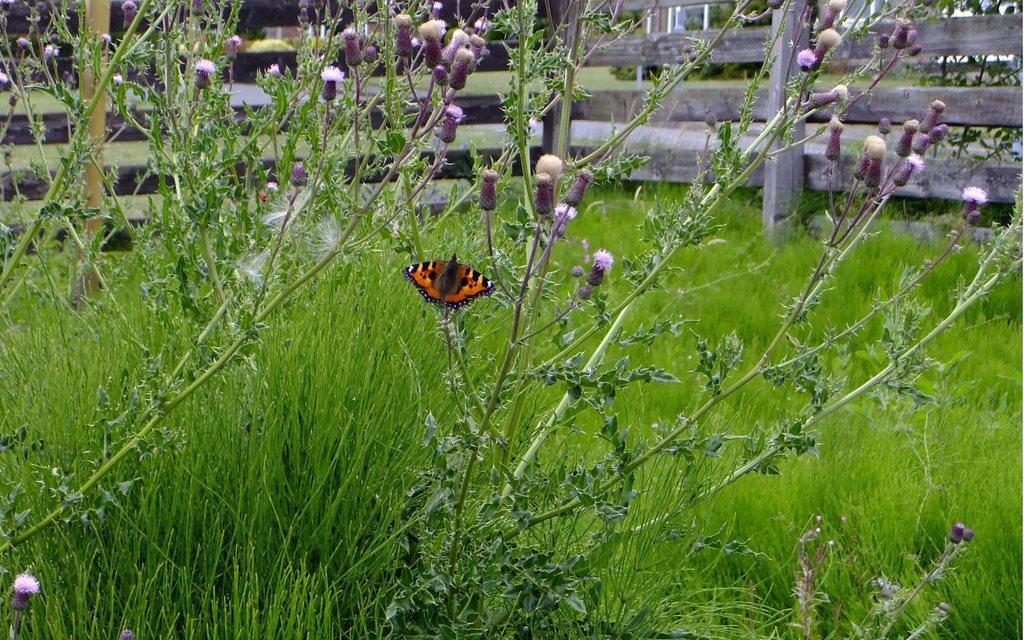Please provide a concise description of this image. In this picture in the middle, we can see a butterfly which is attached to a plant. In the background, we can see some plants, flowers, wood grill, trees, at the bottom there is a grass. 